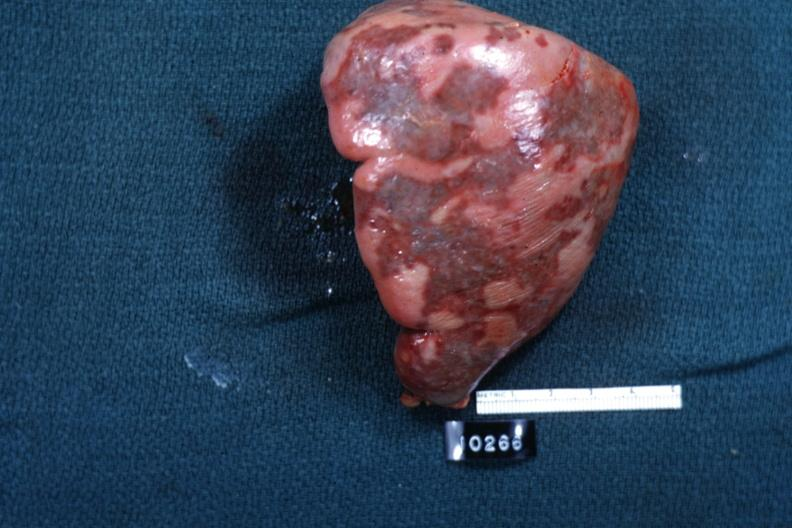s all the fat necrosis slide?
Answer the question using a single word or phrase. No 